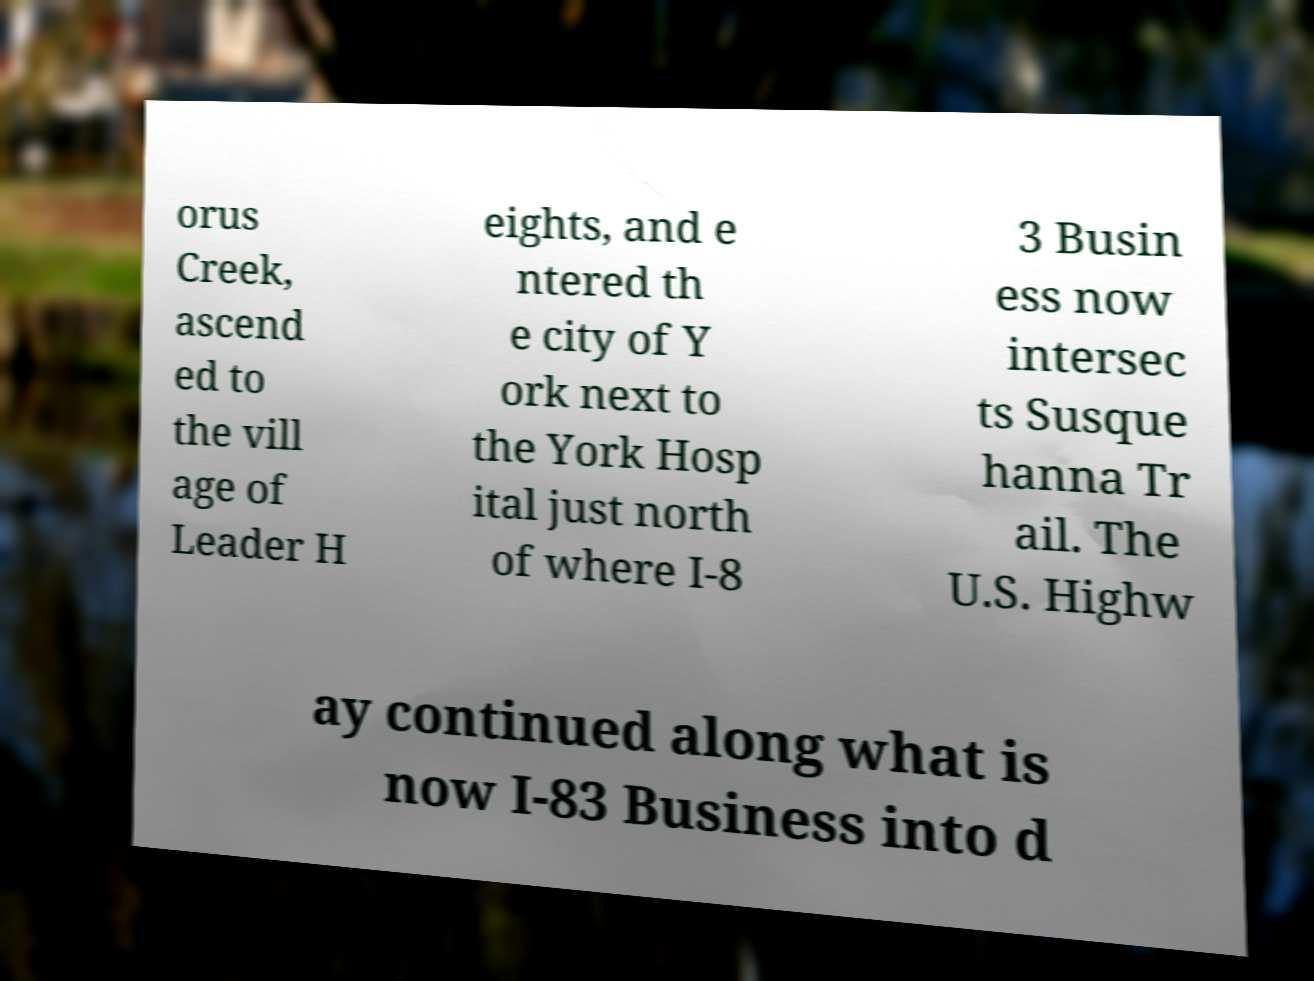For documentation purposes, I need the text within this image transcribed. Could you provide that? orus Creek, ascend ed to the vill age of Leader H eights, and e ntered th e city of Y ork next to the York Hosp ital just north of where I-8 3 Busin ess now intersec ts Susque hanna Tr ail. The U.S. Highw ay continued along what is now I-83 Business into d 